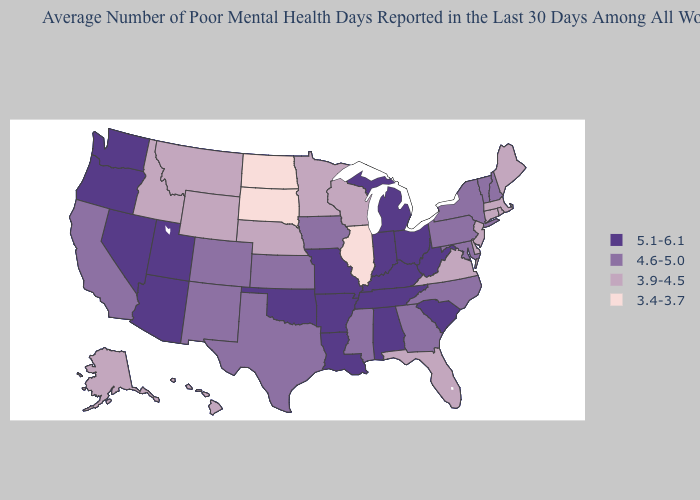Among the states that border Indiana , which have the lowest value?
Give a very brief answer. Illinois. What is the lowest value in the West?
Give a very brief answer. 3.9-4.5. Which states have the lowest value in the South?
Concise answer only. Delaware, Florida, Virginia. What is the lowest value in the West?
Give a very brief answer. 3.9-4.5. Does the map have missing data?
Concise answer only. No. Which states have the highest value in the USA?
Short answer required. Alabama, Arizona, Arkansas, Indiana, Kentucky, Louisiana, Michigan, Missouri, Nevada, Ohio, Oklahoma, Oregon, South Carolina, Tennessee, Utah, Washington, West Virginia. What is the value of Arkansas?
Short answer required. 5.1-6.1. What is the value of Kansas?
Quick response, please. 4.6-5.0. What is the highest value in the MidWest ?
Keep it brief. 5.1-6.1. Which states have the lowest value in the USA?
Quick response, please. Illinois, North Dakota, South Dakota. Does Florida have the lowest value in the South?
Answer briefly. Yes. Name the states that have a value in the range 5.1-6.1?
Short answer required. Alabama, Arizona, Arkansas, Indiana, Kentucky, Louisiana, Michigan, Missouri, Nevada, Ohio, Oklahoma, Oregon, South Carolina, Tennessee, Utah, Washington, West Virginia. What is the value of Arkansas?
Concise answer only. 5.1-6.1. Name the states that have a value in the range 3.9-4.5?
Keep it brief. Alaska, Connecticut, Delaware, Florida, Hawaii, Idaho, Maine, Massachusetts, Minnesota, Montana, Nebraska, New Jersey, Rhode Island, Virginia, Wisconsin, Wyoming. Among the states that border Michigan , does Indiana have the lowest value?
Keep it brief. No. 